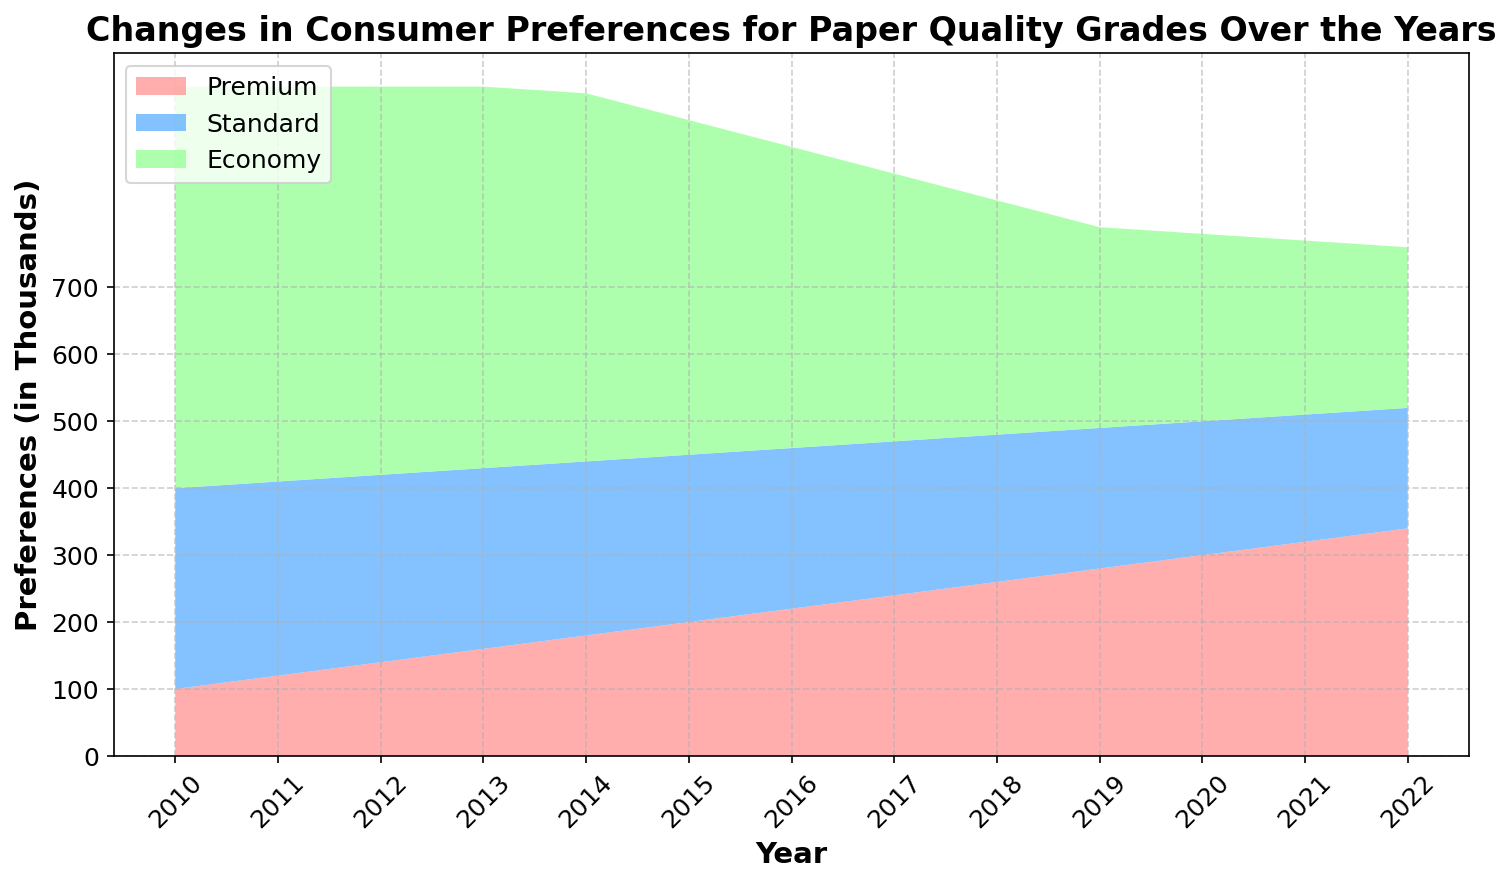What is the trend in consumer preference for Premium paper from 2010 to 2022? The area representing Premium paper consistently increases over the years, indicating a rising trend in consumer preference. From 100,000 in 2010 to 340,000 in 2022.
Answer: Rising trend Between which years does the preference for Standard paper show the steepest decline? By visually inspecting the decrease in the height of the Standard paper area, the steepest decline is between 2020 and 2022. The number decreases from 200,000 in 2010 to 180,000 in 2022.
Answer: 2020-2022 How does consumer preference for Economy paper change over the years? The area representing Economy paper diminishes steadily over time, showing a decrease from 600,000 in 2010 to 240,000 in 2022.
Answer: Decreases steadily By how much did the preference for Economy paper change from 2010 to 2022? In 2010, the preference for Economy paper was 600,000, and in 2022 it was 240,000. The change is 600,000 - 240,000 = 360,000.
Answer: 360,000 Which quality grade had the highest consumer preference in 2015? In 2015, visually, the area representing Economy paper is the largest, so it had the highest consumer preference.
Answer: Economy By how much did the preference for Premium paper increase from 2010 to 2016? In 2010, Premium paper had 100,000 preferences, and in 2016 it had 220,000. The increase is 220,000 - 100,000 = 120,000.
Answer: 120,000 What is the average preference for Standard paper over the years? Sum of Standard paper preferences from 2010 to 2022 divided by the number of years gives the average: (300 + 290 + 280 + 270 + 260 + 250 + 240 + 230 + 220 + 210 + 200 + 190 + 180) / 13 ≈ 243.
Answer: 243 In which year did Premium paper preference surpass 300,000? By observing the increase in the Premium paper area, it surpasses 300,000 in the year 2020.
Answer: 2020 